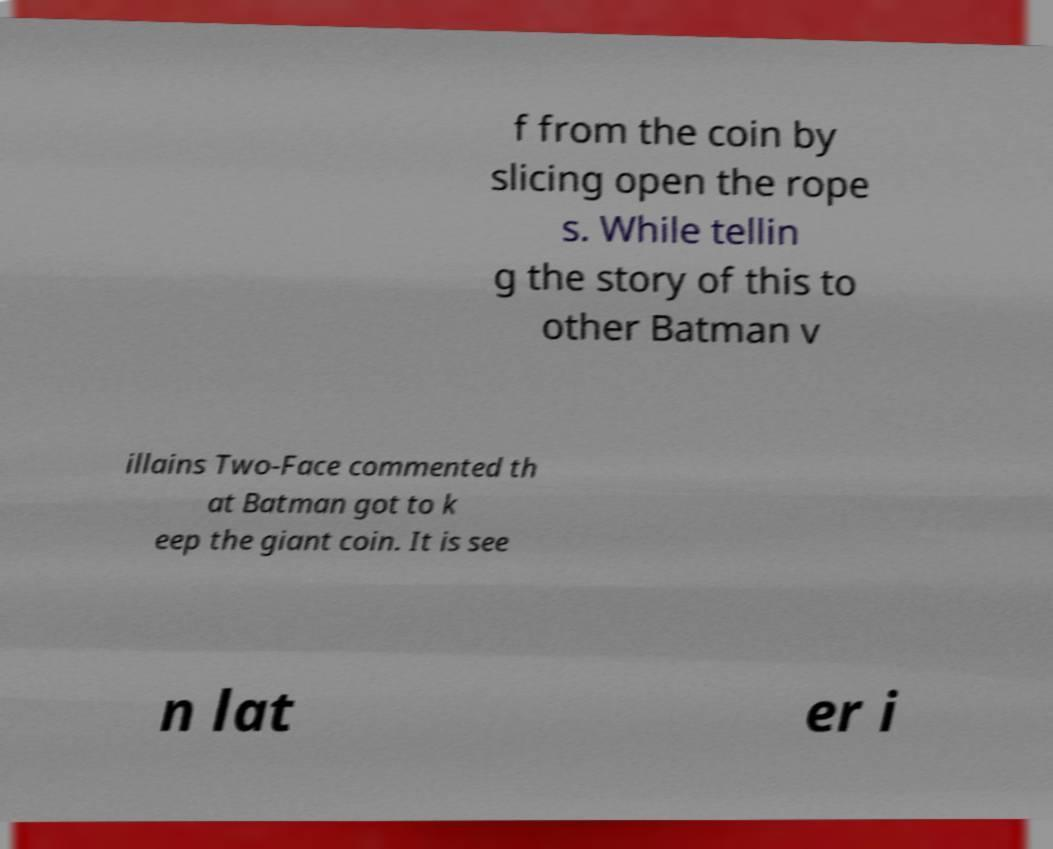Could you assist in decoding the text presented in this image and type it out clearly? f from the coin by slicing open the rope s. While tellin g the story of this to other Batman v illains Two-Face commented th at Batman got to k eep the giant coin. It is see n lat er i 